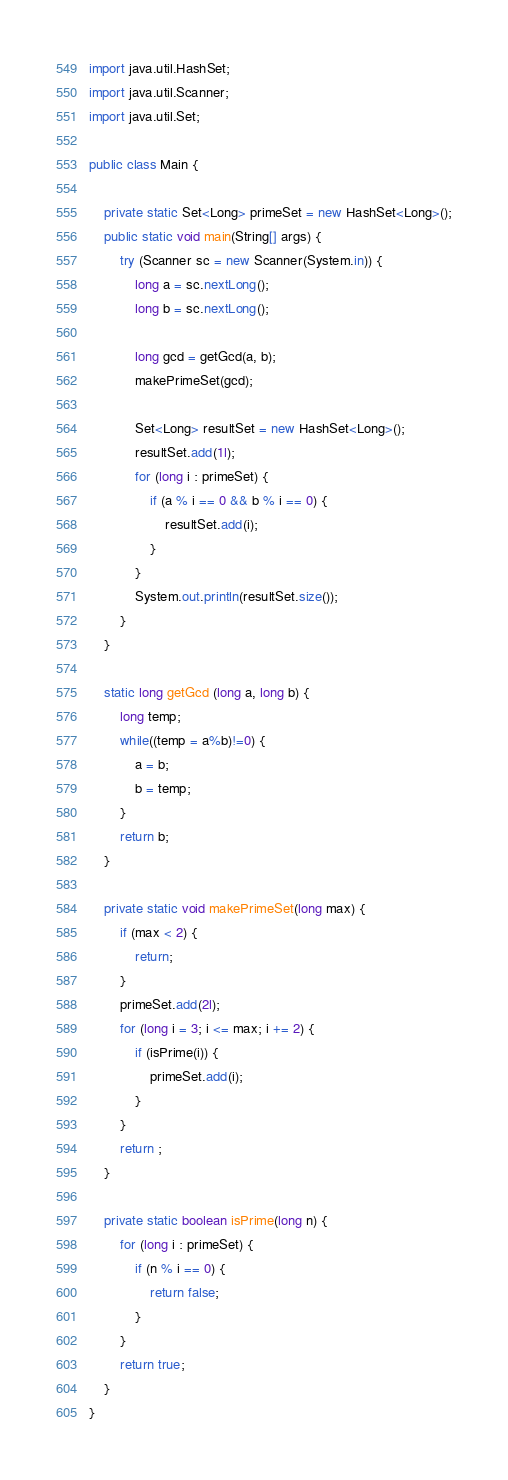Convert code to text. <code><loc_0><loc_0><loc_500><loc_500><_Java_>
import java.util.HashSet;
import java.util.Scanner;
import java.util.Set;

public class Main {

	private static Set<Long> primeSet = new HashSet<Long>();
	public static void main(String[] args) {
		try (Scanner sc = new Scanner(System.in)) {
			long a = sc.nextLong();
			long b = sc.nextLong();

			long gcd = getGcd(a, b);
			makePrimeSet(gcd);

			Set<Long> resultSet = new HashSet<Long>();
			resultSet.add(1l);
			for (long i : primeSet) {
				if (a % i == 0 && b % i == 0) {
					resultSet.add(i);
				}
			}
			System.out.println(resultSet.size());
		}
	}

	static long getGcd (long a, long b) {
		long temp;
		while((temp = a%b)!=0) {
			a = b;
			b = temp;
		}
		return b;
	}

	private static void makePrimeSet(long max) {
		if (max < 2) {
			return;
		}
		primeSet.add(2l);
		for (long i = 3; i <= max; i += 2) {
			if (isPrime(i)) {
				primeSet.add(i);
			}
		}
		return ;
	}

	private static boolean isPrime(long n) {
		for (long i : primeSet) {
			if (n % i == 0) {
				return false;
			}
		}
		return true;
	}
}
</code> 